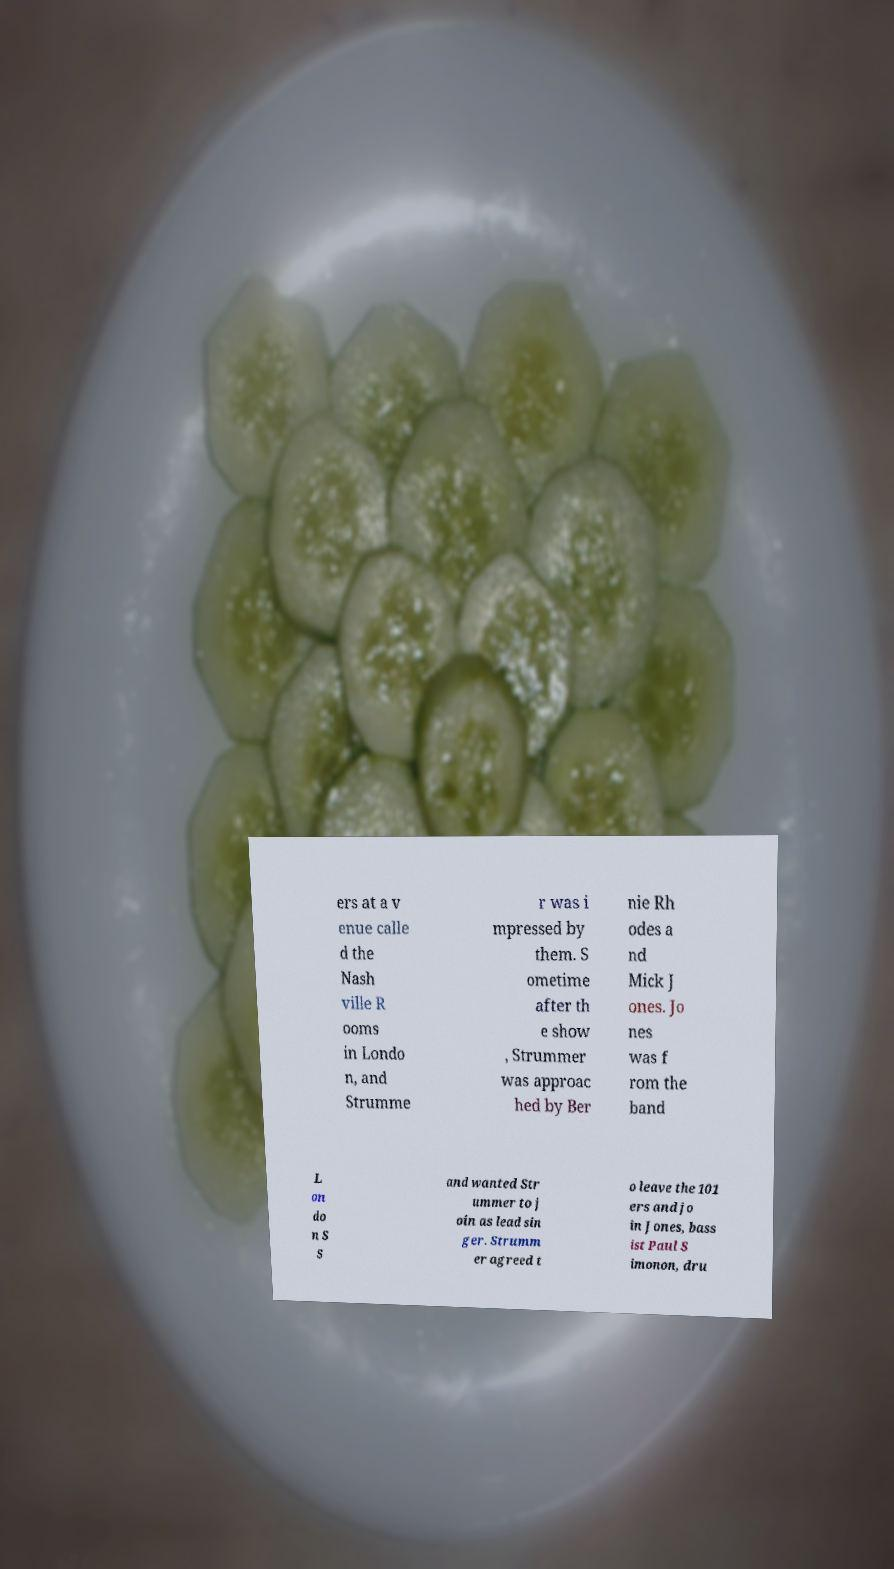Please read and relay the text visible in this image. What does it say? ers at a v enue calle d the Nash ville R ooms in Londo n, and Strumme r was i mpressed by them. S ometime after th e show , Strummer was approac hed by Ber nie Rh odes a nd Mick J ones. Jo nes was f rom the band L on do n S S and wanted Str ummer to j oin as lead sin ger. Strumm er agreed t o leave the 101 ers and jo in Jones, bass ist Paul S imonon, dru 